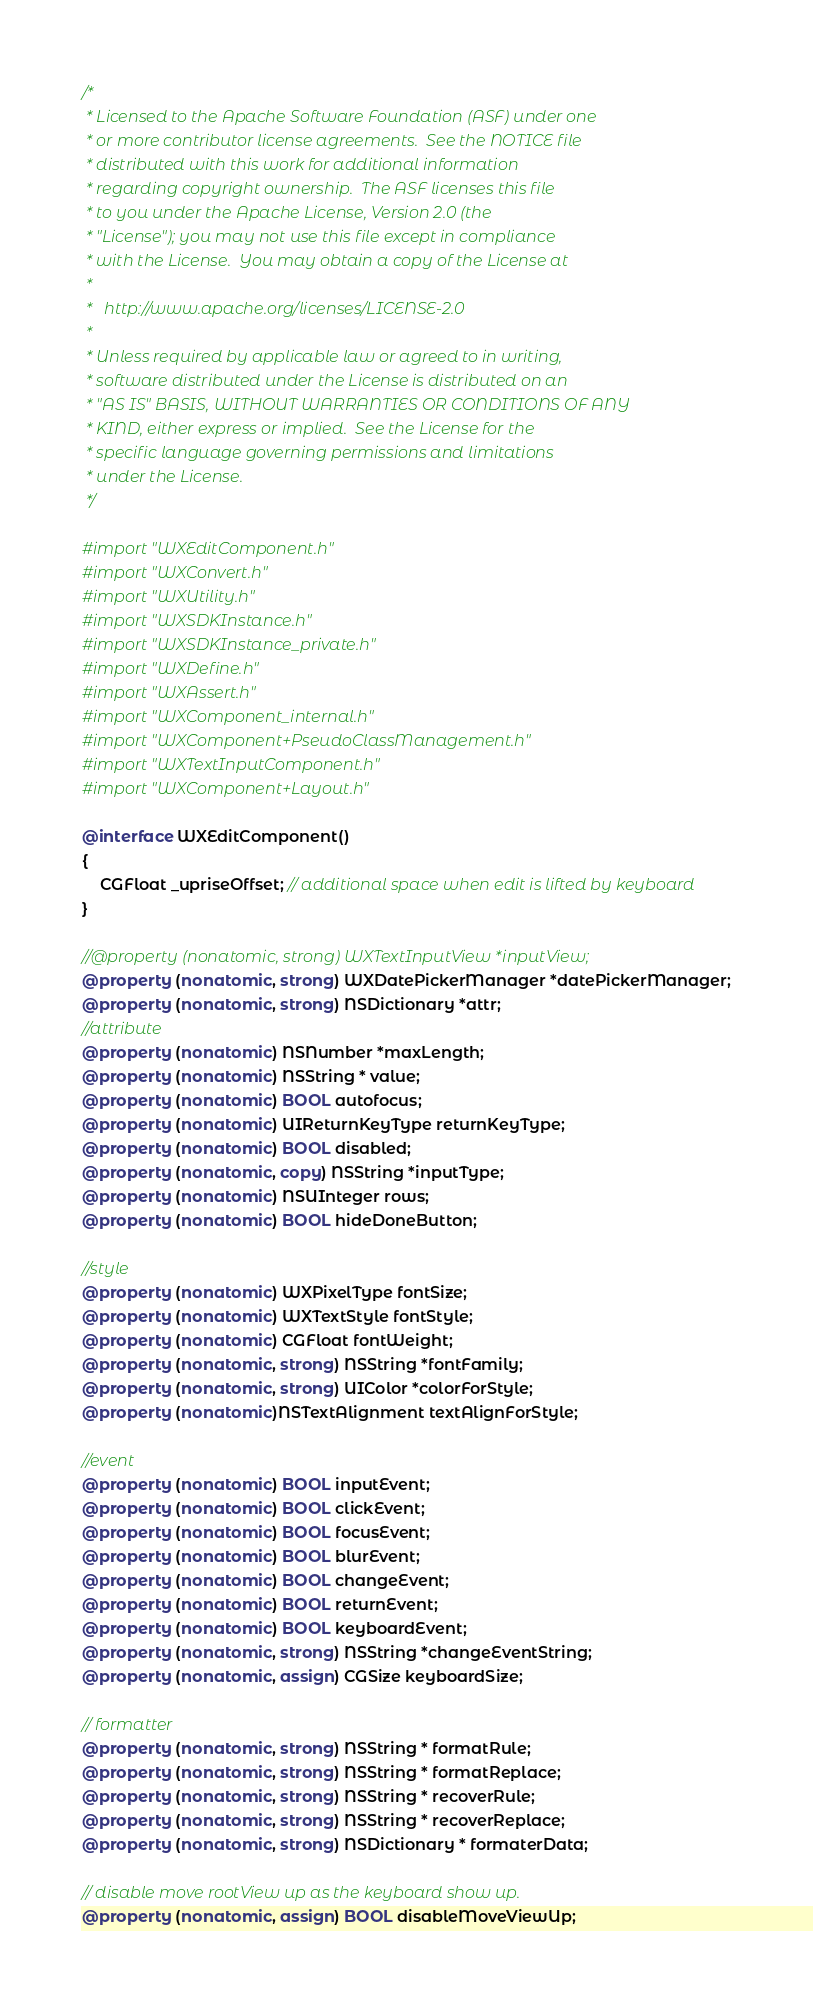Convert code to text. <code><loc_0><loc_0><loc_500><loc_500><_ObjectiveC_>/*
 * Licensed to the Apache Software Foundation (ASF) under one
 * or more contributor license agreements.  See the NOTICE file
 * distributed with this work for additional information
 * regarding copyright ownership.  The ASF licenses this file
 * to you under the Apache License, Version 2.0 (the
 * "License"); you may not use this file except in compliance
 * with the License.  You may obtain a copy of the License at
 *
 *   http://www.apache.org/licenses/LICENSE-2.0
 *
 * Unless required by applicable law or agreed to in writing,
 * software distributed under the License is distributed on an
 * "AS IS" BASIS, WITHOUT WARRANTIES OR CONDITIONS OF ANY
 * KIND, either express or implied.  See the License for the
 * specific language governing permissions and limitations
 * under the License.
 */

#import "WXEditComponent.h"
#import "WXConvert.h"
#import "WXUtility.h"
#import "WXSDKInstance.h"
#import "WXSDKInstance_private.h"
#import "WXDefine.h"
#import "WXAssert.h"
#import "WXComponent_internal.h"
#import "WXComponent+PseudoClassManagement.h"
#import "WXTextInputComponent.h"
#import "WXComponent+Layout.h"

@interface WXEditComponent()
{
    CGFloat _upriseOffset; // additional space when edit is lifted by keyboard
}

//@property (nonatomic, strong) WXTextInputView *inputView;
@property (nonatomic, strong) WXDatePickerManager *datePickerManager;
@property (nonatomic, strong) NSDictionary *attr;
//attribute
@property (nonatomic) NSNumber *maxLength;
@property (nonatomic) NSString * value;
@property (nonatomic) BOOL autofocus;
@property (nonatomic) UIReturnKeyType returnKeyType;
@property (nonatomic) BOOL disabled;
@property (nonatomic, copy) NSString *inputType;
@property (nonatomic) NSUInteger rows;
@property (nonatomic) BOOL hideDoneButton;

//style
@property (nonatomic) WXPixelType fontSize;
@property (nonatomic) WXTextStyle fontStyle;
@property (nonatomic) CGFloat fontWeight;
@property (nonatomic, strong) NSString *fontFamily;
@property (nonatomic, strong) UIColor *colorForStyle;
@property (nonatomic)NSTextAlignment textAlignForStyle;

//event
@property (nonatomic) BOOL inputEvent;
@property (nonatomic) BOOL clickEvent;
@property (nonatomic) BOOL focusEvent;
@property (nonatomic) BOOL blurEvent;
@property (nonatomic) BOOL changeEvent;
@property (nonatomic) BOOL returnEvent;
@property (nonatomic) BOOL keyboardEvent;
@property (nonatomic, strong) NSString *changeEventString;
@property (nonatomic, assign) CGSize keyboardSize;

// formatter
@property (nonatomic, strong) NSString * formatRule;
@property (nonatomic, strong) NSString * formatReplace;
@property (nonatomic, strong) NSString * recoverRule;
@property (nonatomic, strong) NSString * recoverReplace;
@property (nonatomic, strong) NSDictionary * formaterData;

// disable move rootView up as the keyboard show up.
@property (nonatomic, assign) BOOL disableMoveViewUp;
</code> 